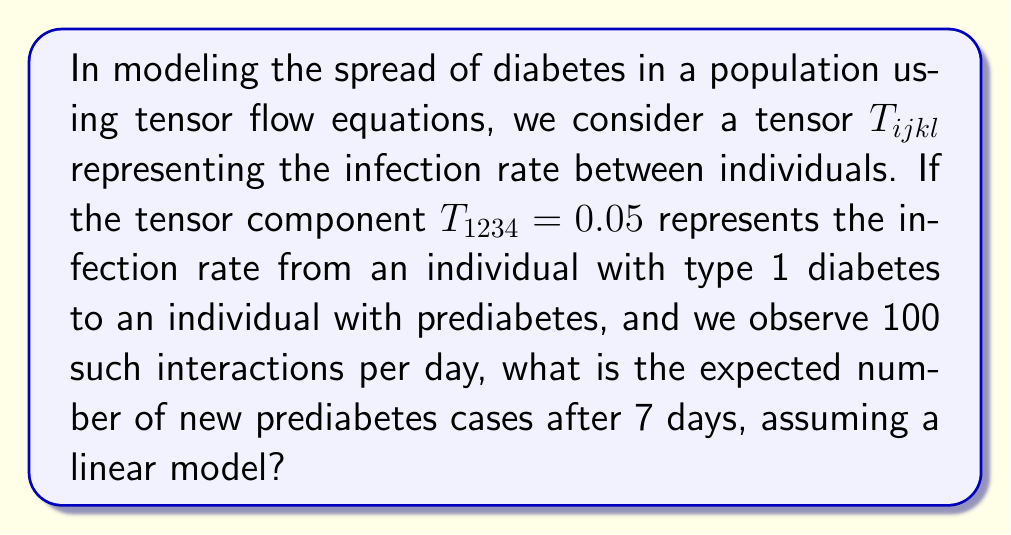Show me your answer to this math problem. To solve this problem, we'll follow these steps:

1) First, let's understand what the tensor component means:
   $T_{1234} = 0.05$ represents the probability of infection from type 1 diabetes to prediabetes per interaction.

2) We're told there are 100 such interactions per day. So, the expected number of new cases per day is:

   $$E(\text{new cases per day}) = T_{1234} \times \text{number of interactions}$$
   $$E(\text{new cases per day}) = 0.05 \times 100 = 5$$

3) We want to know the number of new cases after 7 days. Assuming a linear model, we multiply the daily rate by the number of days:

   $$E(\text{new cases in 7 days}) = E(\text{new cases per day}) \times \text{number of days}$$
   $$E(\text{new cases in 7 days}) = 5 \times 7 = 35$$

Therefore, the expected number of new prediabetes cases after 7 days is 35.
Answer: 35 